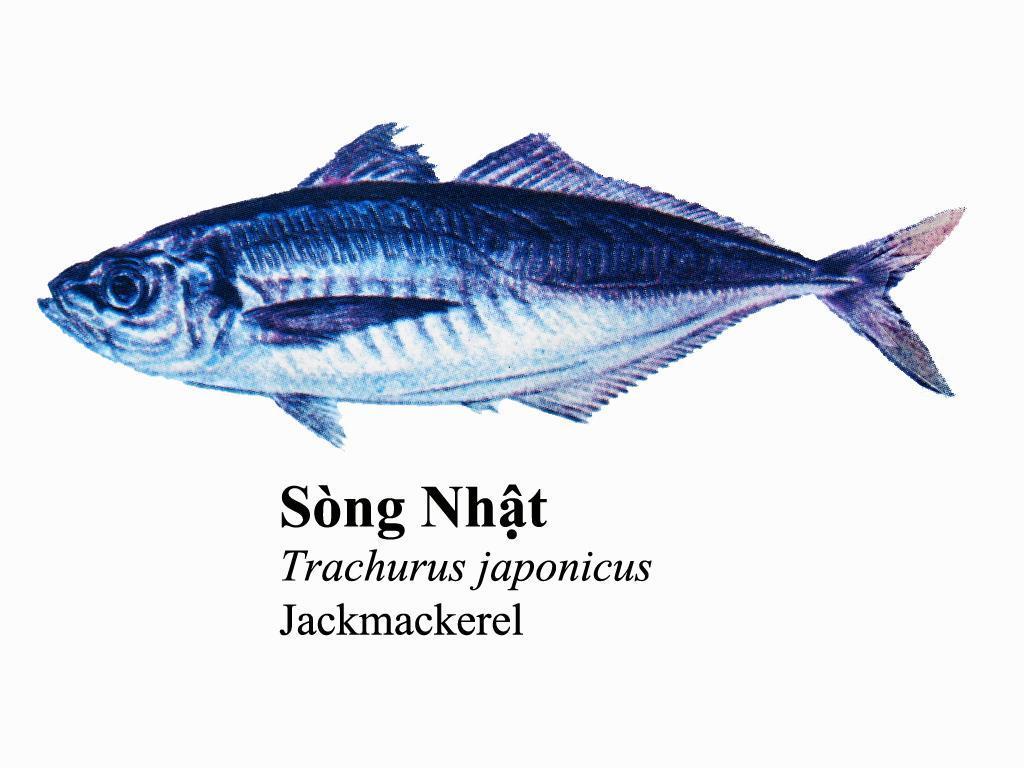How would you summarize this image in a sentence or two? In the center of the image we can see a fish, which is in a blue color. At the bottom of the image, we can see some text. And we can see the white color background. 